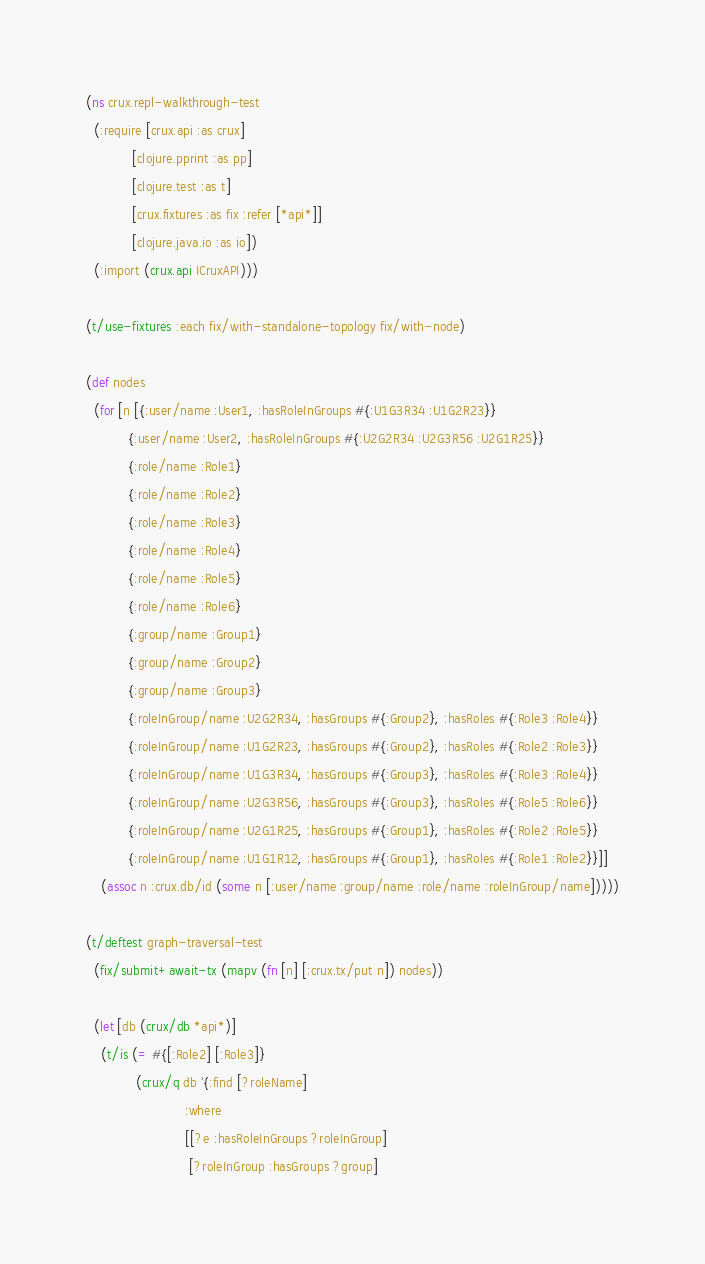Convert code to text. <code><loc_0><loc_0><loc_500><loc_500><_Clojure_>(ns crux.repl-walkthrough-test
  (:require [crux.api :as crux]
            [clojure.pprint :as pp]
            [clojure.test :as t]
            [crux.fixtures :as fix :refer [*api*]]
            [clojure.java.io :as io])
  (:import (crux.api ICruxAPI)))

(t/use-fixtures :each fix/with-standalone-topology fix/with-node)

(def nodes
  (for [n [{:user/name :User1, :hasRoleInGroups #{:U1G3R34 :U1G2R23}}
           {:user/name :User2, :hasRoleInGroups #{:U2G2R34 :U2G3R56 :U2G1R25}}
           {:role/name :Role1}
           {:role/name :Role2}
           {:role/name :Role3}
           {:role/name :Role4}
           {:role/name :Role5}
           {:role/name :Role6}
           {:group/name :Group1}
           {:group/name :Group2}
           {:group/name :Group3}
           {:roleInGroup/name :U2G2R34, :hasGroups #{:Group2}, :hasRoles #{:Role3 :Role4}}
           {:roleInGroup/name :U1G2R23, :hasGroups #{:Group2}, :hasRoles #{:Role2 :Role3}}
           {:roleInGroup/name :U1G3R34, :hasGroups #{:Group3}, :hasRoles #{:Role3 :Role4}}
           {:roleInGroup/name :U2G3R56, :hasGroups #{:Group3}, :hasRoles #{:Role5 :Role6}}
           {:roleInGroup/name :U2G1R25, :hasGroups #{:Group1}, :hasRoles #{:Role2 :Role5}}
           {:roleInGroup/name :U1G1R12, :hasGroups #{:Group1}, :hasRoles #{:Role1 :Role2}}]]
    (assoc n :crux.db/id (some n [:user/name :group/name :role/name :roleInGroup/name]))))

(t/deftest graph-traversal-test
  (fix/submit+await-tx (mapv (fn [n] [:crux.tx/put n]) nodes))

  (let [db (crux/db *api*)]
    (t/is (= #{[:Role2] [:Role3]}
             (crux/q db '{:find [?roleName]
                          :where
                          [[?e :hasRoleInGroups ?roleInGroup]
                           [?roleInGroup :hasGroups ?group]</code> 